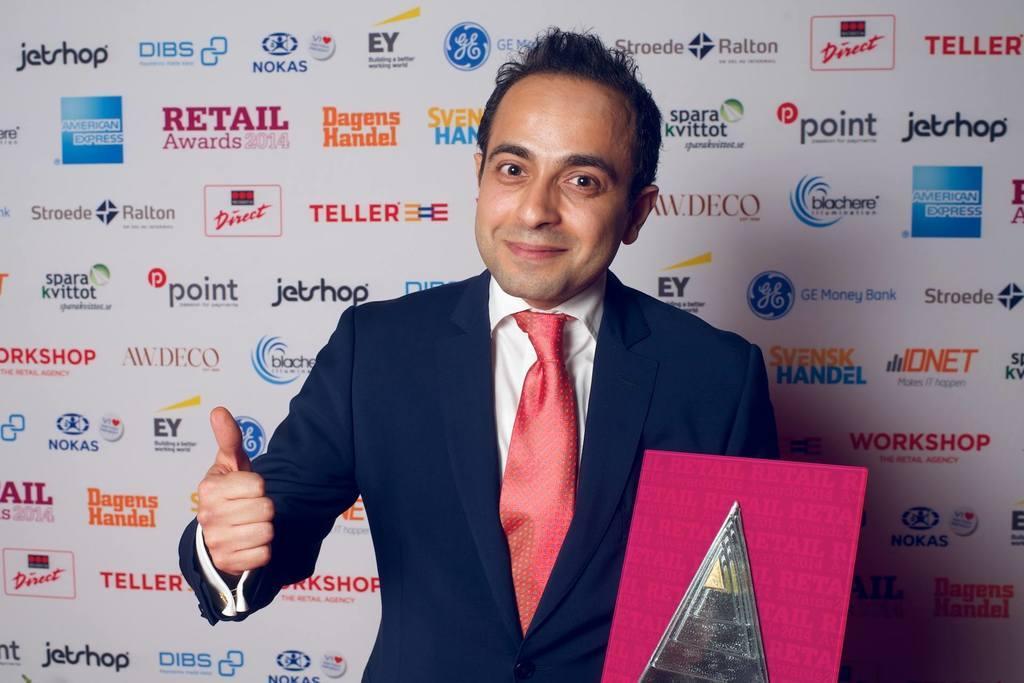Can you describe this image briefly? In this picture there is a person wearing suit is standing and holding an object in his hand and there is a banner behind him. 